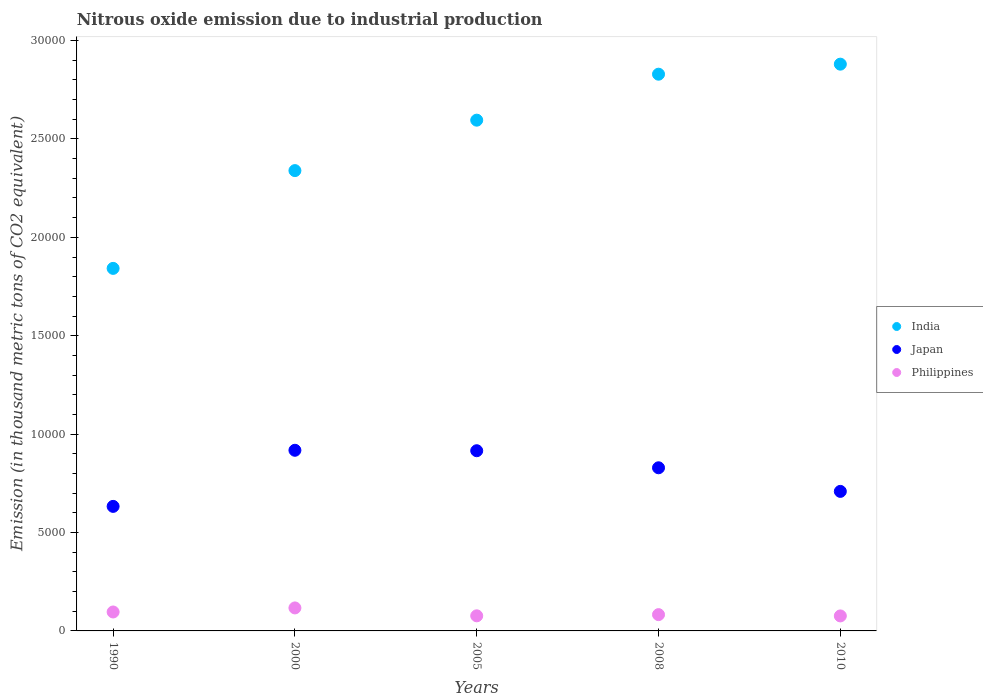Is the number of dotlines equal to the number of legend labels?
Provide a succinct answer. Yes. What is the amount of nitrous oxide emitted in Philippines in 2008?
Give a very brief answer. 828. Across all years, what is the maximum amount of nitrous oxide emitted in Japan?
Keep it short and to the point. 9179.4. Across all years, what is the minimum amount of nitrous oxide emitted in India?
Keep it short and to the point. 1.84e+04. In which year was the amount of nitrous oxide emitted in Philippines maximum?
Your answer should be compact. 2000. In which year was the amount of nitrous oxide emitted in Philippines minimum?
Make the answer very short. 2010. What is the total amount of nitrous oxide emitted in Japan in the graph?
Your response must be concise. 4.00e+04. What is the difference between the amount of nitrous oxide emitted in Japan in 2008 and that in 2010?
Provide a short and direct response. 1199.4. What is the difference between the amount of nitrous oxide emitted in Japan in 2000 and the amount of nitrous oxide emitted in India in 2010?
Your answer should be compact. -1.96e+04. What is the average amount of nitrous oxide emitted in Japan per year?
Give a very brief answer. 8009.08. In the year 2008, what is the difference between the amount of nitrous oxide emitted in Japan and amount of nitrous oxide emitted in Philippines?
Ensure brevity in your answer.  7462. In how many years, is the amount of nitrous oxide emitted in India greater than 13000 thousand metric tons?
Make the answer very short. 5. What is the ratio of the amount of nitrous oxide emitted in Japan in 2008 to that in 2010?
Your answer should be compact. 1.17. Is the amount of nitrous oxide emitted in Philippines in 1990 less than that in 2005?
Make the answer very short. No. Is the difference between the amount of nitrous oxide emitted in Japan in 1990 and 2010 greater than the difference between the amount of nitrous oxide emitted in Philippines in 1990 and 2010?
Offer a terse response. No. What is the difference between the highest and the second highest amount of nitrous oxide emitted in India?
Give a very brief answer. 510. What is the difference between the highest and the lowest amount of nitrous oxide emitted in Philippines?
Your answer should be very brief. 406.6. Is the sum of the amount of nitrous oxide emitted in India in 2008 and 2010 greater than the maximum amount of nitrous oxide emitted in Philippines across all years?
Your response must be concise. Yes. Does the amount of nitrous oxide emitted in Japan monotonically increase over the years?
Ensure brevity in your answer.  No. Is the amount of nitrous oxide emitted in India strictly less than the amount of nitrous oxide emitted in Japan over the years?
Make the answer very short. No. How many dotlines are there?
Offer a very short reply. 3. How many years are there in the graph?
Keep it short and to the point. 5. Are the values on the major ticks of Y-axis written in scientific E-notation?
Give a very brief answer. No. Does the graph contain any zero values?
Ensure brevity in your answer.  No. Where does the legend appear in the graph?
Provide a succinct answer. Center right. What is the title of the graph?
Provide a short and direct response. Nitrous oxide emission due to industrial production. Does "Poland" appear as one of the legend labels in the graph?
Provide a succinct answer. No. What is the label or title of the X-axis?
Keep it short and to the point. Years. What is the label or title of the Y-axis?
Your answer should be very brief. Emission (in thousand metric tons of CO2 equivalent). What is the Emission (in thousand metric tons of CO2 equivalent) in India in 1990?
Give a very brief answer. 1.84e+04. What is the Emission (in thousand metric tons of CO2 equivalent) of Japan in 1990?
Your response must be concise. 6328.4. What is the Emission (in thousand metric tons of CO2 equivalent) in Philippines in 1990?
Ensure brevity in your answer.  962.4. What is the Emission (in thousand metric tons of CO2 equivalent) in India in 2000?
Provide a succinct answer. 2.34e+04. What is the Emission (in thousand metric tons of CO2 equivalent) of Japan in 2000?
Give a very brief answer. 9179.4. What is the Emission (in thousand metric tons of CO2 equivalent) in Philippines in 2000?
Offer a very short reply. 1168.7. What is the Emission (in thousand metric tons of CO2 equivalent) of India in 2005?
Ensure brevity in your answer.  2.60e+04. What is the Emission (in thousand metric tons of CO2 equivalent) of Japan in 2005?
Provide a succinct answer. 9157. What is the Emission (in thousand metric tons of CO2 equivalent) in Philippines in 2005?
Provide a succinct answer. 767.6. What is the Emission (in thousand metric tons of CO2 equivalent) of India in 2008?
Make the answer very short. 2.83e+04. What is the Emission (in thousand metric tons of CO2 equivalent) of Japan in 2008?
Offer a very short reply. 8290. What is the Emission (in thousand metric tons of CO2 equivalent) in Philippines in 2008?
Make the answer very short. 828. What is the Emission (in thousand metric tons of CO2 equivalent) of India in 2010?
Make the answer very short. 2.88e+04. What is the Emission (in thousand metric tons of CO2 equivalent) in Japan in 2010?
Ensure brevity in your answer.  7090.6. What is the Emission (in thousand metric tons of CO2 equivalent) of Philippines in 2010?
Give a very brief answer. 762.1. Across all years, what is the maximum Emission (in thousand metric tons of CO2 equivalent) in India?
Give a very brief answer. 2.88e+04. Across all years, what is the maximum Emission (in thousand metric tons of CO2 equivalent) in Japan?
Provide a succinct answer. 9179.4. Across all years, what is the maximum Emission (in thousand metric tons of CO2 equivalent) of Philippines?
Your response must be concise. 1168.7. Across all years, what is the minimum Emission (in thousand metric tons of CO2 equivalent) of India?
Make the answer very short. 1.84e+04. Across all years, what is the minimum Emission (in thousand metric tons of CO2 equivalent) of Japan?
Make the answer very short. 6328.4. Across all years, what is the minimum Emission (in thousand metric tons of CO2 equivalent) in Philippines?
Provide a succinct answer. 762.1. What is the total Emission (in thousand metric tons of CO2 equivalent) of India in the graph?
Your answer should be compact. 1.25e+05. What is the total Emission (in thousand metric tons of CO2 equivalent) in Japan in the graph?
Your answer should be compact. 4.00e+04. What is the total Emission (in thousand metric tons of CO2 equivalent) in Philippines in the graph?
Keep it short and to the point. 4488.8. What is the difference between the Emission (in thousand metric tons of CO2 equivalent) in India in 1990 and that in 2000?
Make the answer very short. -4968.5. What is the difference between the Emission (in thousand metric tons of CO2 equivalent) of Japan in 1990 and that in 2000?
Provide a succinct answer. -2851. What is the difference between the Emission (in thousand metric tons of CO2 equivalent) in Philippines in 1990 and that in 2000?
Your answer should be very brief. -206.3. What is the difference between the Emission (in thousand metric tons of CO2 equivalent) of India in 1990 and that in 2005?
Ensure brevity in your answer.  -7531.6. What is the difference between the Emission (in thousand metric tons of CO2 equivalent) in Japan in 1990 and that in 2005?
Provide a short and direct response. -2828.6. What is the difference between the Emission (in thousand metric tons of CO2 equivalent) in Philippines in 1990 and that in 2005?
Keep it short and to the point. 194.8. What is the difference between the Emission (in thousand metric tons of CO2 equivalent) of India in 1990 and that in 2008?
Keep it short and to the point. -9867.5. What is the difference between the Emission (in thousand metric tons of CO2 equivalent) of Japan in 1990 and that in 2008?
Your answer should be very brief. -1961.6. What is the difference between the Emission (in thousand metric tons of CO2 equivalent) in Philippines in 1990 and that in 2008?
Make the answer very short. 134.4. What is the difference between the Emission (in thousand metric tons of CO2 equivalent) of India in 1990 and that in 2010?
Provide a short and direct response. -1.04e+04. What is the difference between the Emission (in thousand metric tons of CO2 equivalent) in Japan in 1990 and that in 2010?
Make the answer very short. -762.2. What is the difference between the Emission (in thousand metric tons of CO2 equivalent) of Philippines in 1990 and that in 2010?
Keep it short and to the point. 200.3. What is the difference between the Emission (in thousand metric tons of CO2 equivalent) in India in 2000 and that in 2005?
Ensure brevity in your answer.  -2563.1. What is the difference between the Emission (in thousand metric tons of CO2 equivalent) in Japan in 2000 and that in 2005?
Give a very brief answer. 22.4. What is the difference between the Emission (in thousand metric tons of CO2 equivalent) in Philippines in 2000 and that in 2005?
Your answer should be very brief. 401.1. What is the difference between the Emission (in thousand metric tons of CO2 equivalent) in India in 2000 and that in 2008?
Ensure brevity in your answer.  -4899. What is the difference between the Emission (in thousand metric tons of CO2 equivalent) of Japan in 2000 and that in 2008?
Ensure brevity in your answer.  889.4. What is the difference between the Emission (in thousand metric tons of CO2 equivalent) of Philippines in 2000 and that in 2008?
Your answer should be very brief. 340.7. What is the difference between the Emission (in thousand metric tons of CO2 equivalent) of India in 2000 and that in 2010?
Offer a terse response. -5409. What is the difference between the Emission (in thousand metric tons of CO2 equivalent) of Japan in 2000 and that in 2010?
Provide a succinct answer. 2088.8. What is the difference between the Emission (in thousand metric tons of CO2 equivalent) in Philippines in 2000 and that in 2010?
Offer a terse response. 406.6. What is the difference between the Emission (in thousand metric tons of CO2 equivalent) of India in 2005 and that in 2008?
Your response must be concise. -2335.9. What is the difference between the Emission (in thousand metric tons of CO2 equivalent) of Japan in 2005 and that in 2008?
Give a very brief answer. 867. What is the difference between the Emission (in thousand metric tons of CO2 equivalent) of Philippines in 2005 and that in 2008?
Offer a very short reply. -60.4. What is the difference between the Emission (in thousand metric tons of CO2 equivalent) in India in 2005 and that in 2010?
Ensure brevity in your answer.  -2845.9. What is the difference between the Emission (in thousand metric tons of CO2 equivalent) in Japan in 2005 and that in 2010?
Offer a very short reply. 2066.4. What is the difference between the Emission (in thousand metric tons of CO2 equivalent) of Philippines in 2005 and that in 2010?
Your answer should be very brief. 5.5. What is the difference between the Emission (in thousand metric tons of CO2 equivalent) of India in 2008 and that in 2010?
Your answer should be compact. -510. What is the difference between the Emission (in thousand metric tons of CO2 equivalent) in Japan in 2008 and that in 2010?
Provide a succinct answer. 1199.4. What is the difference between the Emission (in thousand metric tons of CO2 equivalent) in Philippines in 2008 and that in 2010?
Make the answer very short. 65.9. What is the difference between the Emission (in thousand metric tons of CO2 equivalent) in India in 1990 and the Emission (in thousand metric tons of CO2 equivalent) in Japan in 2000?
Your answer should be very brief. 9243.4. What is the difference between the Emission (in thousand metric tons of CO2 equivalent) of India in 1990 and the Emission (in thousand metric tons of CO2 equivalent) of Philippines in 2000?
Offer a terse response. 1.73e+04. What is the difference between the Emission (in thousand metric tons of CO2 equivalent) in Japan in 1990 and the Emission (in thousand metric tons of CO2 equivalent) in Philippines in 2000?
Make the answer very short. 5159.7. What is the difference between the Emission (in thousand metric tons of CO2 equivalent) of India in 1990 and the Emission (in thousand metric tons of CO2 equivalent) of Japan in 2005?
Keep it short and to the point. 9265.8. What is the difference between the Emission (in thousand metric tons of CO2 equivalent) in India in 1990 and the Emission (in thousand metric tons of CO2 equivalent) in Philippines in 2005?
Offer a very short reply. 1.77e+04. What is the difference between the Emission (in thousand metric tons of CO2 equivalent) in Japan in 1990 and the Emission (in thousand metric tons of CO2 equivalent) in Philippines in 2005?
Your answer should be very brief. 5560.8. What is the difference between the Emission (in thousand metric tons of CO2 equivalent) of India in 1990 and the Emission (in thousand metric tons of CO2 equivalent) of Japan in 2008?
Give a very brief answer. 1.01e+04. What is the difference between the Emission (in thousand metric tons of CO2 equivalent) in India in 1990 and the Emission (in thousand metric tons of CO2 equivalent) in Philippines in 2008?
Give a very brief answer. 1.76e+04. What is the difference between the Emission (in thousand metric tons of CO2 equivalent) in Japan in 1990 and the Emission (in thousand metric tons of CO2 equivalent) in Philippines in 2008?
Your answer should be very brief. 5500.4. What is the difference between the Emission (in thousand metric tons of CO2 equivalent) of India in 1990 and the Emission (in thousand metric tons of CO2 equivalent) of Japan in 2010?
Ensure brevity in your answer.  1.13e+04. What is the difference between the Emission (in thousand metric tons of CO2 equivalent) in India in 1990 and the Emission (in thousand metric tons of CO2 equivalent) in Philippines in 2010?
Your answer should be very brief. 1.77e+04. What is the difference between the Emission (in thousand metric tons of CO2 equivalent) in Japan in 1990 and the Emission (in thousand metric tons of CO2 equivalent) in Philippines in 2010?
Provide a short and direct response. 5566.3. What is the difference between the Emission (in thousand metric tons of CO2 equivalent) of India in 2000 and the Emission (in thousand metric tons of CO2 equivalent) of Japan in 2005?
Provide a succinct answer. 1.42e+04. What is the difference between the Emission (in thousand metric tons of CO2 equivalent) of India in 2000 and the Emission (in thousand metric tons of CO2 equivalent) of Philippines in 2005?
Offer a terse response. 2.26e+04. What is the difference between the Emission (in thousand metric tons of CO2 equivalent) of Japan in 2000 and the Emission (in thousand metric tons of CO2 equivalent) of Philippines in 2005?
Offer a very short reply. 8411.8. What is the difference between the Emission (in thousand metric tons of CO2 equivalent) in India in 2000 and the Emission (in thousand metric tons of CO2 equivalent) in Japan in 2008?
Ensure brevity in your answer.  1.51e+04. What is the difference between the Emission (in thousand metric tons of CO2 equivalent) in India in 2000 and the Emission (in thousand metric tons of CO2 equivalent) in Philippines in 2008?
Make the answer very short. 2.26e+04. What is the difference between the Emission (in thousand metric tons of CO2 equivalent) of Japan in 2000 and the Emission (in thousand metric tons of CO2 equivalent) of Philippines in 2008?
Offer a terse response. 8351.4. What is the difference between the Emission (in thousand metric tons of CO2 equivalent) of India in 2000 and the Emission (in thousand metric tons of CO2 equivalent) of Japan in 2010?
Your answer should be compact. 1.63e+04. What is the difference between the Emission (in thousand metric tons of CO2 equivalent) in India in 2000 and the Emission (in thousand metric tons of CO2 equivalent) in Philippines in 2010?
Ensure brevity in your answer.  2.26e+04. What is the difference between the Emission (in thousand metric tons of CO2 equivalent) in Japan in 2000 and the Emission (in thousand metric tons of CO2 equivalent) in Philippines in 2010?
Give a very brief answer. 8417.3. What is the difference between the Emission (in thousand metric tons of CO2 equivalent) of India in 2005 and the Emission (in thousand metric tons of CO2 equivalent) of Japan in 2008?
Provide a succinct answer. 1.77e+04. What is the difference between the Emission (in thousand metric tons of CO2 equivalent) of India in 2005 and the Emission (in thousand metric tons of CO2 equivalent) of Philippines in 2008?
Give a very brief answer. 2.51e+04. What is the difference between the Emission (in thousand metric tons of CO2 equivalent) of Japan in 2005 and the Emission (in thousand metric tons of CO2 equivalent) of Philippines in 2008?
Keep it short and to the point. 8329. What is the difference between the Emission (in thousand metric tons of CO2 equivalent) of India in 2005 and the Emission (in thousand metric tons of CO2 equivalent) of Japan in 2010?
Ensure brevity in your answer.  1.89e+04. What is the difference between the Emission (in thousand metric tons of CO2 equivalent) of India in 2005 and the Emission (in thousand metric tons of CO2 equivalent) of Philippines in 2010?
Offer a terse response. 2.52e+04. What is the difference between the Emission (in thousand metric tons of CO2 equivalent) in Japan in 2005 and the Emission (in thousand metric tons of CO2 equivalent) in Philippines in 2010?
Provide a succinct answer. 8394.9. What is the difference between the Emission (in thousand metric tons of CO2 equivalent) in India in 2008 and the Emission (in thousand metric tons of CO2 equivalent) in Japan in 2010?
Your answer should be compact. 2.12e+04. What is the difference between the Emission (in thousand metric tons of CO2 equivalent) of India in 2008 and the Emission (in thousand metric tons of CO2 equivalent) of Philippines in 2010?
Your answer should be compact. 2.75e+04. What is the difference between the Emission (in thousand metric tons of CO2 equivalent) in Japan in 2008 and the Emission (in thousand metric tons of CO2 equivalent) in Philippines in 2010?
Provide a succinct answer. 7527.9. What is the average Emission (in thousand metric tons of CO2 equivalent) in India per year?
Keep it short and to the point. 2.50e+04. What is the average Emission (in thousand metric tons of CO2 equivalent) in Japan per year?
Your answer should be very brief. 8009.08. What is the average Emission (in thousand metric tons of CO2 equivalent) in Philippines per year?
Your answer should be compact. 897.76. In the year 1990, what is the difference between the Emission (in thousand metric tons of CO2 equivalent) in India and Emission (in thousand metric tons of CO2 equivalent) in Japan?
Your answer should be very brief. 1.21e+04. In the year 1990, what is the difference between the Emission (in thousand metric tons of CO2 equivalent) in India and Emission (in thousand metric tons of CO2 equivalent) in Philippines?
Offer a terse response. 1.75e+04. In the year 1990, what is the difference between the Emission (in thousand metric tons of CO2 equivalent) of Japan and Emission (in thousand metric tons of CO2 equivalent) of Philippines?
Offer a very short reply. 5366. In the year 2000, what is the difference between the Emission (in thousand metric tons of CO2 equivalent) in India and Emission (in thousand metric tons of CO2 equivalent) in Japan?
Provide a succinct answer. 1.42e+04. In the year 2000, what is the difference between the Emission (in thousand metric tons of CO2 equivalent) in India and Emission (in thousand metric tons of CO2 equivalent) in Philippines?
Keep it short and to the point. 2.22e+04. In the year 2000, what is the difference between the Emission (in thousand metric tons of CO2 equivalent) of Japan and Emission (in thousand metric tons of CO2 equivalent) of Philippines?
Offer a very short reply. 8010.7. In the year 2005, what is the difference between the Emission (in thousand metric tons of CO2 equivalent) in India and Emission (in thousand metric tons of CO2 equivalent) in Japan?
Offer a terse response. 1.68e+04. In the year 2005, what is the difference between the Emission (in thousand metric tons of CO2 equivalent) of India and Emission (in thousand metric tons of CO2 equivalent) of Philippines?
Your answer should be compact. 2.52e+04. In the year 2005, what is the difference between the Emission (in thousand metric tons of CO2 equivalent) in Japan and Emission (in thousand metric tons of CO2 equivalent) in Philippines?
Offer a very short reply. 8389.4. In the year 2008, what is the difference between the Emission (in thousand metric tons of CO2 equivalent) of India and Emission (in thousand metric tons of CO2 equivalent) of Japan?
Give a very brief answer. 2.00e+04. In the year 2008, what is the difference between the Emission (in thousand metric tons of CO2 equivalent) in India and Emission (in thousand metric tons of CO2 equivalent) in Philippines?
Give a very brief answer. 2.75e+04. In the year 2008, what is the difference between the Emission (in thousand metric tons of CO2 equivalent) in Japan and Emission (in thousand metric tons of CO2 equivalent) in Philippines?
Keep it short and to the point. 7462. In the year 2010, what is the difference between the Emission (in thousand metric tons of CO2 equivalent) of India and Emission (in thousand metric tons of CO2 equivalent) of Japan?
Keep it short and to the point. 2.17e+04. In the year 2010, what is the difference between the Emission (in thousand metric tons of CO2 equivalent) of India and Emission (in thousand metric tons of CO2 equivalent) of Philippines?
Offer a very short reply. 2.80e+04. In the year 2010, what is the difference between the Emission (in thousand metric tons of CO2 equivalent) in Japan and Emission (in thousand metric tons of CO2 equivalent) in Philippines?
Your answer should be very brief. 6328.5. What is the ratio of the Emission (in thousand metric tons of CO2 equivalent) in India in 1990 to that in 2000?
Your answer should be very brief. 0.79. What is the ratio of the Emission (in thousand metric tons of CO2 equivalent) of Japan in 1990 to that in 2000?
Your answer should be compact. 0.69. What is the ratio of the Emission (in thousand metric tons of CO2 equivalent) in Philippines in 1990 to that in 2000?
Provide a succinct answer. 0.82. What is the ratio of the Emission (in thousand metric tons of CO2 equivalent) in India in 1990 to that in 2005?
Give a very brief answer. 0.71. What is the ratio of the Emission (in thousand metric tons of CO2 equivalent) of Japan in 1990 to that in 2005?
Offer a very short reply. 0.69. What is the ratio of the Emission (in thousand metric tons of CO2 equivalent) in Philippines in 1990 to that in 2005?
Provide a short and direct response. 1.25. What is the ratio of the Emission (in thousand metric tons of CO2 equivalent) of India in 1990 to that in 2008?
Make the answer very short. 0.65. What is the ratio of the Emission (in thousand metric tons of CO2 equivalent) of Japan in 1990 to that in 2008?
Offer a terse response. 0.76. What is the ratio of the Emission (in thousand metric tons of CO2 equivalent) of Philippines in 1990 to that in 2008?
Provide a succinct answer. 1.16. What is the ratio of the Emission (in thousand metric tons of CO2 equivalent) of India in 1990 to that in 2010?
Provide a short and direct response. 0.64. What is the ratio of the Emission (in thousand metric tons of CO2 equivalent) of Japan in 1990 to that in 2010?
Provide a short and direct response. 0.89. What is the ratio of the Emission (in thousand metric tons of CO2 equivalent) in Philippines in 1990 to that in 2010?
Give a very brief answer. 1.26. What is the ratio of the Emission (in thousand metric tons of CO2 equivalent) of India in 2000 to that in 2005?
Provide a succinct answer. 0.9. What is the ratio of the Emission (in thousand metric tons of CO2 equivalent) in Philippines in 2000 to that in 2005?
Offer a very short reply. 1.52. What is the ratio of the Emission (in thousand metric tons of CO2 equivalent) in India in 2000 to that in 2008?
Ensure brevity in your answer.  0.83. What is the ratio of the Emission (in thousand metric tons of CO2 equivalent) of Japan in 2000 to that in 2008?
Offer a very short reply. 1.11. What is the ratio of the Emission (in thousand metric tons of CO2 equivalent) in Philippines in 2000 to that in 2008?
Your answer should be compact. 1.41. What is the ratio of the Emission (in thousand metric tons of CO2 equivalent) in India in 2000 to that in 2010?
Your response must be concise. 0.81. What is the ratio of the Emission (in thousand metric tons of CO2 equivalent) in Japan in 2000 to that in 2010?
Give a very brief answer. 1.29. What is the ratio of the Emission (in thousand metric tons of CO2 equivalent) of Philippines in 2000 to that in 2010?
Your response must be concise. 1.53. What is the ratio of the Emission (in thousand metric tons of CO2 equivalent) in India in 2005 to that in 2008?
Give a very brief answer. 0.92. What is the ratio of the Emission (in thousand metric tons of CO2 equivalent) in Japan in 2005 to that in 2008?
Your response must be concise. 1.1. What is the ratio of the Emission (in thousand metric tons of CO2 equivalent) in Philippines in 2005 to that in 2008?
Your answer should be compact. 0.93. What is the ratio of the Emission (in thousand metric tons of CO2 equivalent) in India in 2005 to that in 2010?
Keep it short and to the point. 0.9. What is the ratio of the Emission (in thousand metric tons of CO2 equivalent) of Japan in 2005 to that in 2010?
Offer a very short reply. 1.29. What is the ratio of the Emission (in thousand metric tons of CO2 equivalent) of India in 2008 to that in 2010?
Offer a terse response. 0.98. What is the ratio of the Emission (in thousand metric tons of CO2 equivalent) of Japan in 2008 to that in 2010?
Your answer should be compact. 1.17. What is the ratio of the Emission (in thousand metric tons of CO2 equivalent) in Philippines in 2008 to that in 2010?
Give a very brief answer. 1.09. What is the difference between the highest and the second highest Emission (in thousand metric tons of CO2 equivalent) in India?
Keep it short and to the point. 510. What is the difference between the highest and the second highest Emission (in thousand metric tons of CO2 equivalent) in Japan?
Provide a short and direct response. 22.4. What is the difference between the highest and the second highest Emission (in thousand metric tons of CO2 equivalent) in Philippines?
Offer a terse response. 206.3. What is the difference between the highest and the lowest Emission (in thousand metric tons of CO2 equivalent) of India?
Make the answer very short. 1.04e+04. What is the difference between the highest and the lowest Emission (in thousand metric tons of CO2 equivalent) of Japan?
Keep it short and to the point. 2851. What is the difference between the highest and the lowest Emission (in thousand metric tons of CO2 equivalent) of Philippines?
Your response must be concise. 406.6. 